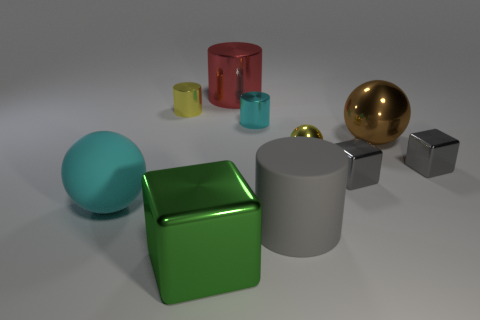Subtract 1 cubes. How many cubes are left? 2 Subtract all purple cylinders. Subtract all brown cubes. How many cylinders are left? 4 Subtract all blocks. How many objects are left? 7 Subtract all big brown cylinders. Subtract all gray matte objects. How many objects are left? 9 Add 5 cyan objects. How many cyan objects are left? 7 Add 6 large spheres. How many large spheres exist? 8 Subtract 1 green blocks. How many objects are left? 9 